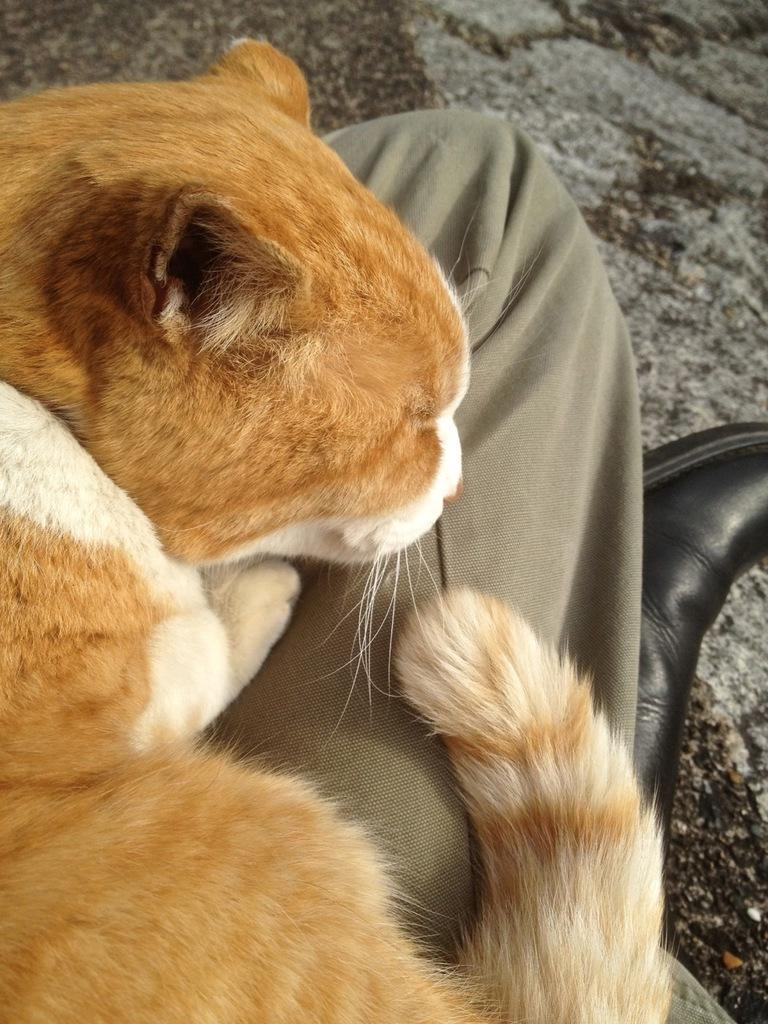What type of animal is in the image? There is a cat in the image. Can you describe the cat's coloring? The cat has brown, cream, and white colors. Where is the cat located in the image? The cat is on a person's lap. What other object can be seen in the image? There is a black-colored shoe in the image. What is visible beneath the cat and the person? The ground is visible in the image. What type of seed is the cat planting in the image? There is no seed or planting activity present in the image; it features a cat on a person's lap and a black-colored shoe. What is the cat using to carry water in the image? There is no pail or water-carrying activity present in the image; it features a cat on a person's lap and a black-colored shoe. 